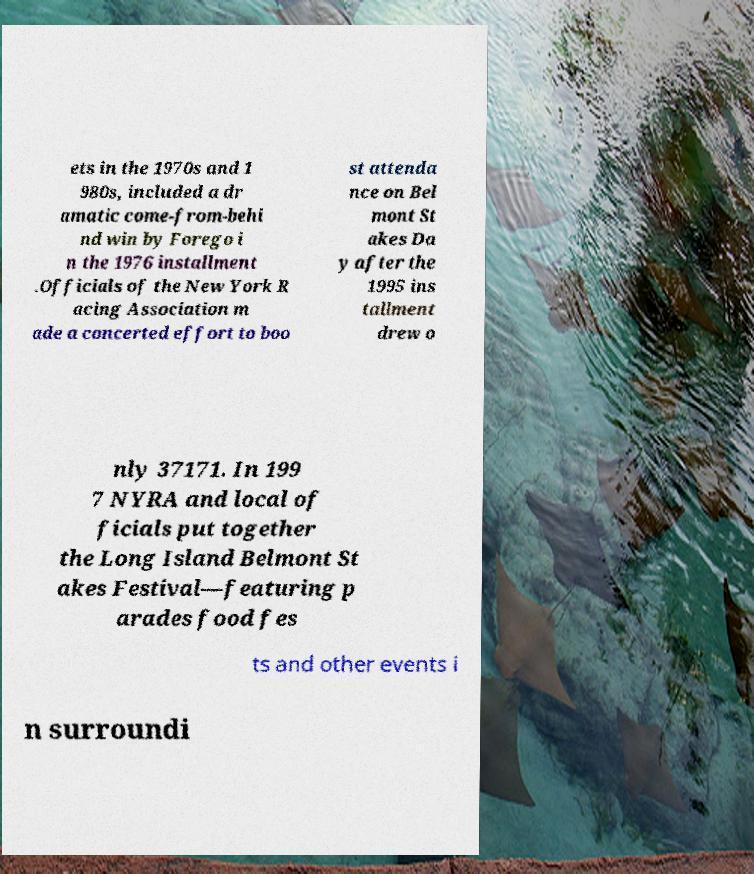There's text embedded in this image that I need extracted. Can you transcribe it verbatim? ets in the 1970s and 1 980s, included a dr amatic come-from-behi nd win by Forego i n the 1976 installment .Officials of the New York R acing Association m ade a concerted effort to boo st attenda nce on Bel mont St akes Da y after the 1995 ins tallment drew o nly 37171. In 199 7 NYRA and local of ficials put together the Long Island Belmont St akes Festival—featuring p arades food fes ts and other events i n surroundi 